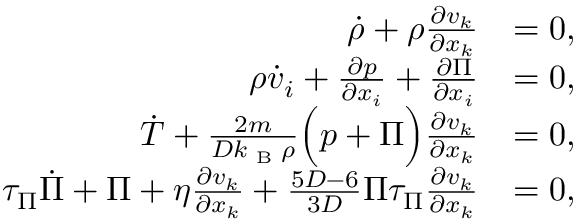Convert formula to latex. <formula><loc_0><loc_0><loc_500><loc_500>\begin{array} { r l } { \dot { \rho } + \rho \frac { \partial v _ { k } } { \partial x _ { k } } } & { = 0 , } \\ { \rho \dot { v } _ { i } + \frac { \partial p } { \partial x _ { i } } + \frac { \partial \Pi } { \partial x _ { i } } } & { = 0 , } \\ { \dot { T } + \frac { 2 m } { D k _ { B } \rho } \left ( p + \Pi \right ) \frac { \partial v _ { k } } { \partial x _ { k } } } & { = 0 , } \\ { \tau _ { \Pi } \dot { \Pi } + \Pi + \eta \frac { \partial v _ { k } } { \partial x _ { k } } + \frac { 5 D - 6 } { 3 D } \Pi \tau _ { \Pi } \frac { \partial v _ { k } } { \partial x _ { k } } } & { = 0 , } \end{array}</formula> 